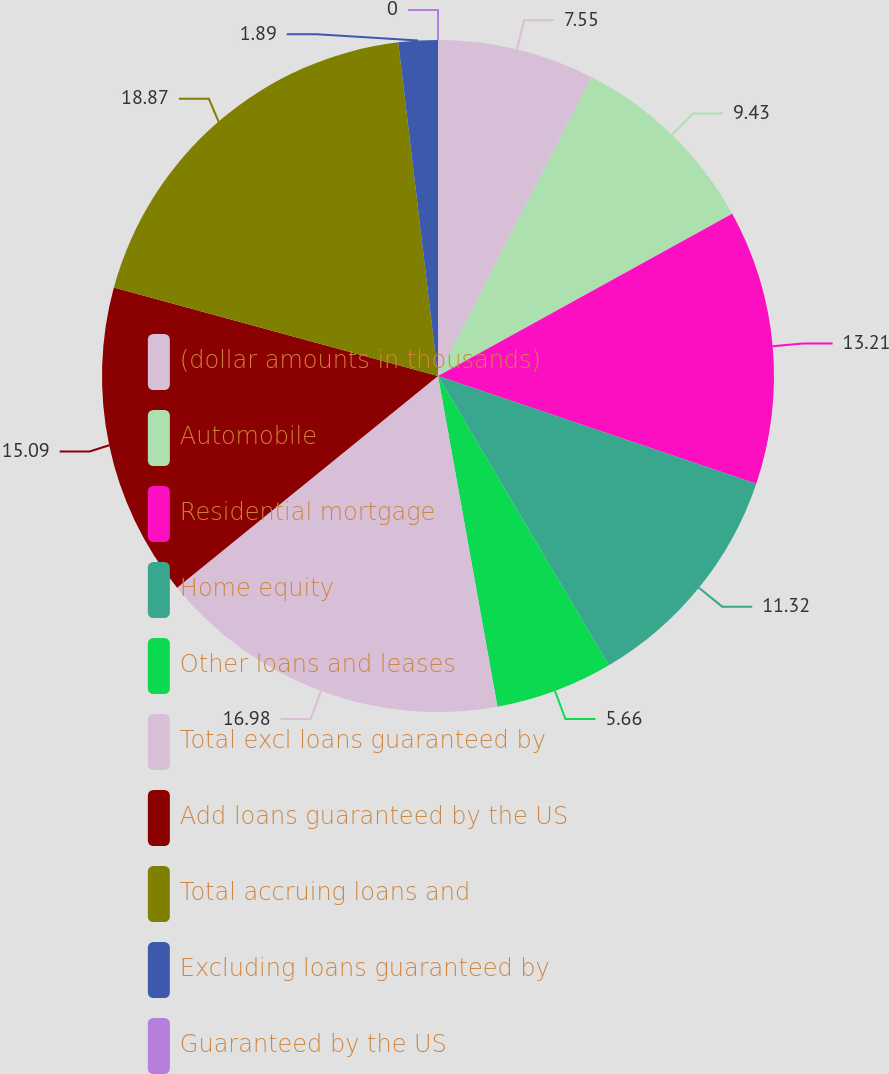Convert chart. <chart><loc_0><loc_0><loc_500><loc_500><pie_chart><fcel>(dollar amounts in thousands)<fcel>Automobile<fcel>Residential mortgage<fcel>Home equity<fcel>Other loans and leases<fcel>Total excl loans guaranteed by<fcel>Add loans guaranteed by the US<fcel>Total accruing loans and<fcel>Excluding loans guaranteed by<fcel>Guaranteed by the US<nl><fcel>7.55%<fcel>9.43%<fcel>13.21%<fcel>11.32%<fcel>5.66%<fcel>16.98%<fcel>15.09%<fcel>18.87%<fcel>1.89%<fcel>0.0%<nl></chart> 